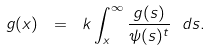Convert formula to latex. <formula><loc_0><loc_0><loc_500><loc_500>g ( x ) \ = \ k \int _ { x } ^ { \infty } \frac { g ( s ) } { \psi ( s ) ^ { t } } \ d s .</formula> 